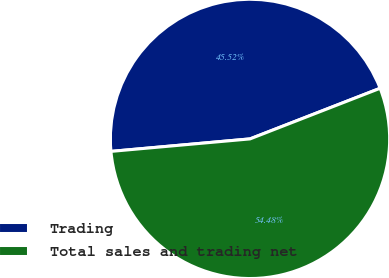<chart> <loc_0><loc_0><loc_500><loc_500><pie_chart><fcel>Trading<fcel>Total sales and trading net<nl><fcel>45.52%<fcel>54.48%<nl></chart> 